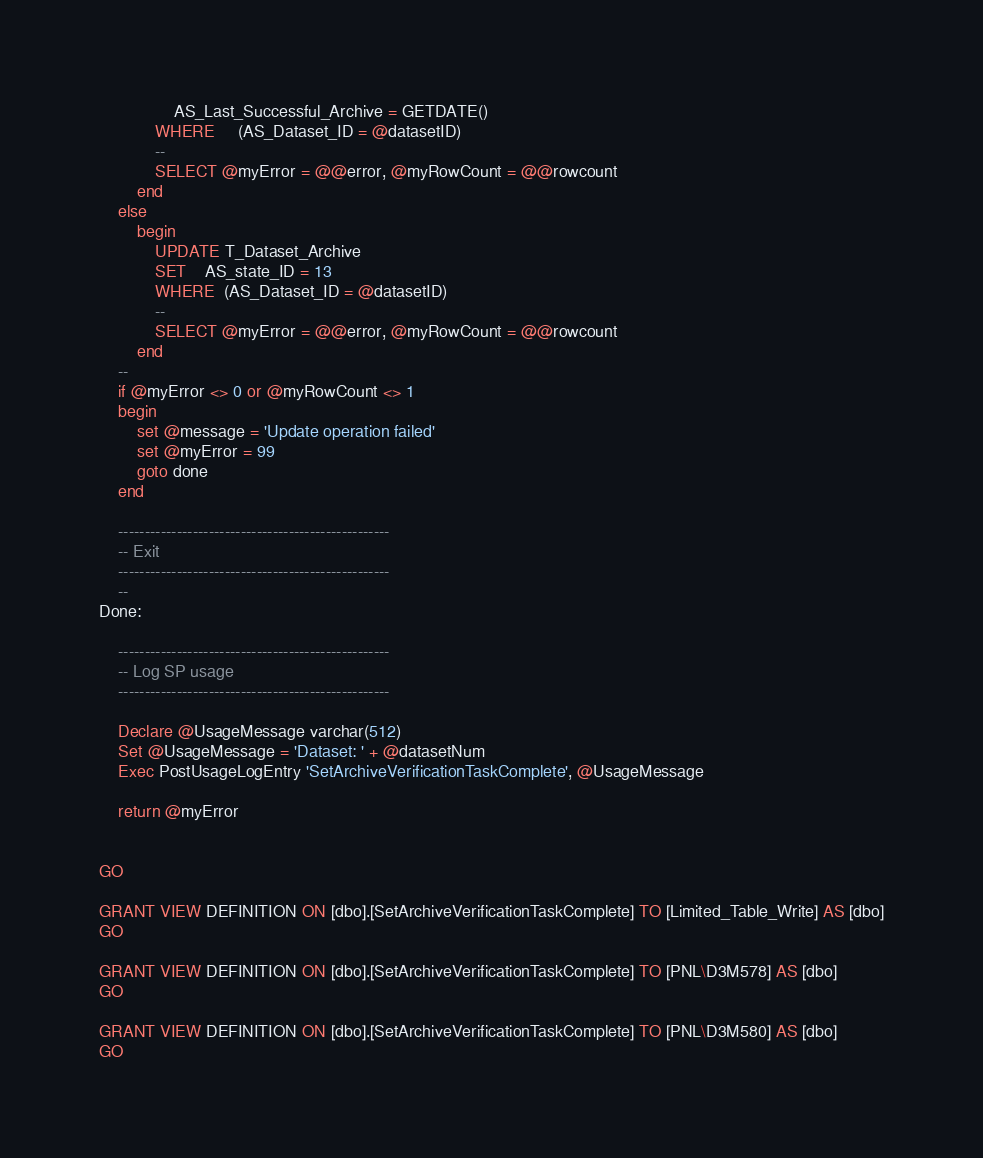Convert code to text. <code><loc_0><loc_0><loc_500><loc_500><_SQL_>				AS_Last_Successful_Archive = GETDATE()
			WHERE     (AS_Dataset_ID = @datasetID)
			--
			SELECT @myError = @@error, @myRowCount = @@rowcount
		end
	else
		begin
			UPDATE T_Dataset_Archive
			SET    AS_state_ID = 13
			WHERE  (AS_Dataset_ID = @datasetID)
			--
			SELECT @myError = @@error, @myRowCount = @@rowcount
		end
	--
	if @myError <> 0 or @myRowCount <> 1
	begin
		set @message = 'Update operation failed'
		set @myError = 99
		goto done
	end

   	---------------------------------------------------
	-- Exit
	---------------------------------------------------
	--
Done:

	---------------------------------------------------
	-- Log SP usage
	---------------------------------------------------

	Declare @UsageMessage varchar(512)
	Set @UsageMessage = 'Dataset: ' + @datasetNum
	Exec PostUsageLogEntry 'SetArchiveVerificationTaskComplete', @UsageMessage

	return @myError


GO

GRANT VIEW DEFINITION ON [dbo].[SetArchiveVerificationTaskComplete] TO [Limited_Table_Write] AS [dbo]
GO

GRANT VIEW DEFINITION ON [dbo].[SetArchiveVerificationTaskComplete] TO [PNL\D3M578] AS [dbo]
GO

GRANT VIEW DEFINITION ON [dbo].[SetArchiveVerificationTaskComplete] TO [PNL\D3M580] AS [dbo]
GO

</code> 